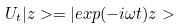<formula> <loc_0><loc_0><loc_500><loc_500>U _ { t } | z > = | e x p ( - i \omega t ) z ></formula> 